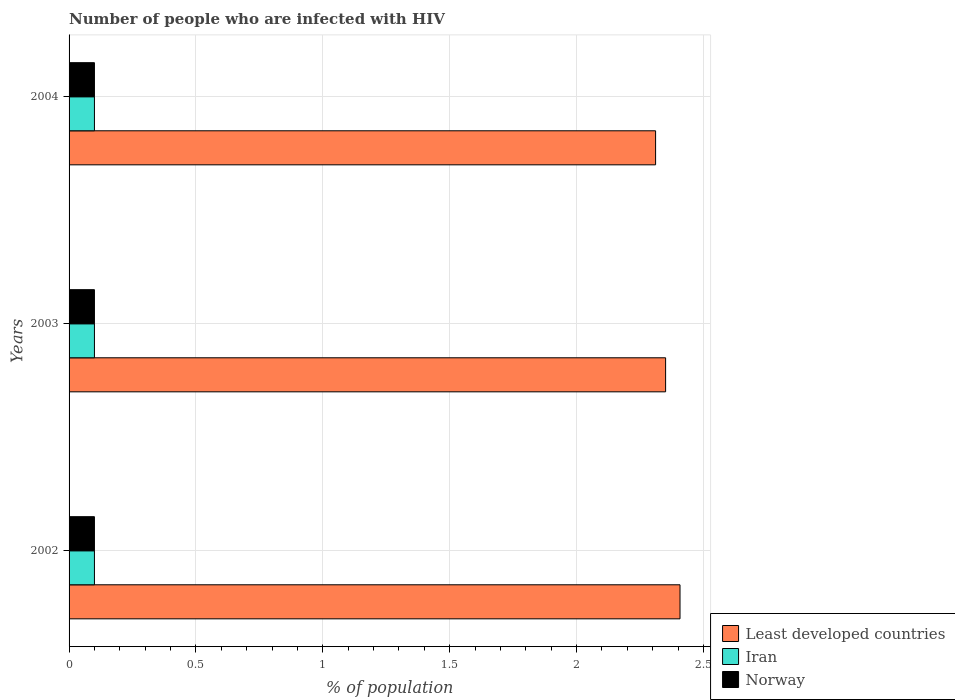Are the number of bars on each tick of the Y-axis equal?
Offer a terse response. Yes. How many bars are there on the 3rd tick from the top?
Keep it short and to the point. 3. How many bars are there on the 3rd tick from the bottom?
Provide a short and direct response. 3. In how many cases, is the number of bars for a given year not equal to the number of legend labels?
Provide a short and direct response. 0. Across all years, what is the maximum percentage of HIV infected population in in Least developed countries?
Make the answer very short. 2.41. Across all years, what is the minimum percentage of HIV infected population in in Iran?
Provide a succinct answer. 0.1. In which year was the percentage of HIV infected population in in Least developed countries minimum?
Ensure brevity in your answer.  2004. What is the total percentage of HIV infected population in in Least developed countries in the graph?
Your answer should be compact. 7.07. What is the average percentage of HIV infected population in in Iran per year?
Offer a terse response. 0.1. In the year 2002, what is the difference between the percentage of HIV infected population in in Least developed countries and percentage of HIV infected population in in Iran?
Make the answer very short. 2.31. What is the difference between the highest and the second highest percentage of HIV infected population in in Iran?
Offer a very short reply. 0. What is the difference between the highest and the lowest percentage of HIV infected population in in Iran?
Make the answer very short. 0. Is the sum of the percentage of HIV infected population in in Least developed countries in 2002 and 2003 greater than the maximum percentage of HIV infected population in in Norway across all years?
Offer a very short reply. Yes. What does the 2nd bar from the top in 2002 represents?
Offer a very short reply. Iran. What does the 2nd bar from the bottom in 2003 represents?
Offer a terse response. Iran. How many bars are there?
Your answer should be compact. 9. Are the values on the major ticks of X-axis written in scientific E-notation?
Give a very brief answer. No. Does the graph contain any zero values?
Offer a terse response. No. What is the title of the graph?
Offer a terse response. Number of people who are infected with HIV. What is the label or title of the X-axis?
Your answer should be very brief. % of population. What is the label or title of the Y-axis?
Make the answer very short. Years. What is the % of population in Least developed countries in 2002?
Offer a very short reply. 2.41. What is the % of population in Least developed countries in 2003?
Provide a short and direct response. 2.35. What is the % of population of Iran in 2003?
Keep it short and to the point. 0.1. What is the % of population in Least developed countries in 2004?
Your response must be concise. 2.31. What is the % of population in Iran in 2004?
Keep it short and to the point. 0.1. What is the % of population of Norway in 2004?
Provide a succinct answer. 0.1. Across all years, what is the maximum % of population in Least developed countries?
Keep it short and to the point. 2.41. Across all years, what is the maximum % of population in Iran?
Give a very brief answer. 0.1. Across all years, what is the maximum % of population of Norway?
Provide a succinct answer. 0.1. Across all years, what is the minimum % of population in Least developed countries?
Offer a very short reply. 2.31. Across all years, what is the minimum % of population in Iran?
Make the answer very short. 0.1. Across all years, what is the minimum % of population of Norway?
Offer a very short reply. 0.1. What is the total % of population in Least developed countries in the graph?
Provide a succinct answer. 7.07. What is the total % of population in Iran in the graph?
Your answer should be very brief. 0.3. What is the difference between the % of population of Least developed countries in 2002 and that in 2003?
Your response must be concise. 0.06. What is the difference between the % of population in Iran in 2002 and that in 2003?
Your answer should be very brief. 0. What is the difference between the % of population in Norway in 2002 and that in 2003?
Provide a succinct answer. 0. What is the difference between the % of population in Least developed countries in 2002 and that in 2004?
Your answer should be compact. 0.1. What is the difference between the % of population in Iran in 2002 and that in 2004?
Your answer should be compact. 0. What is the difference between the % of population in Norway in 2002 and that in 2004?
Your answer should be very brief. 0. What is the difference between the % of population in Least developed countries in 2003 and that in 2004?
Offer a very short reply. 0.04. What is the difference between the % of population in Iran in 2003 and that in 2004?
Keep it short and to the point. 0. What is the difference between the % of population in Least developed countries in 2002 and the % of population in Iran in 2003?
Provide a short and direct response. 2.31. What is the difference between the % of population in Least developed countries in 2002 and the % of population in Norway in 2003?
Your answer should be compact. 2.31. What is the difference between the % of population of Least developed countries in 2002 and the % of population of Iran in 2004?
Ensure brevity in your answer.  2.31. What is the difference between the % of population in Least developed countries in 2002 and the % of population in Norway in 2004?
Your answer should be compact. 2.31. What is the difference between the % of population in Least developed countries in 2003 and the % of population in Iran in 2004?
Make the answer very short. 2.25. What is the difference between the % of population in Least developed countries in 2003 and the % of population in Norway in 2004?
Provide a short and direct response. 2.25. What is the difference between the % of population of Iran in 2003 and the % of population of Norway in 2004?
Keep it short and to the point. 0. What is the average % of population in Least developed countries per year?
Your answer should be compact. 2.36. What is the average % of population of Norway per year?
Keep it short and to the point. 0.1. In the year 2002, what is the difference between the % of population of Least developed countries and % of population of Iran?
Provide a short and direct response. 2.31. In the year 2002, what is the difference between the % of population of Least developed countries and % of population of Norway?
Provide a succinct answer. 2.31. In the year 2002, what is the difference between the % of population in Iran and % of population in Norway?
Ensure brevity in your answer.  0. In the year 2003, what is the difference between the % of population in Least developed countries and % of population in Iran?
Keep it short and to the point. 2.25. In the year 2003, what is the difference between the % of population of Least developed countries and % of population of Norway?
Make the answer very short. 2.25. In the year 2003, what is the difference between the % of population in Iran and % of population in Norway?
Provide a succinct answer. 0. In the year 2004, what is the difference between the % of population in Least developed countries and % of population in Iran?
Offer a very short reply. 2.21. In the year 2004, what is the difference between the % of population in Least developed countries and % of population in Norway?
Give a very brief answer. 2.21. In the year 2004, what is the difference between the % of population in Iran and % of population in Norway?
Give a very brief answer. 0. What is the ratio of the % of population in Least developed countries in 2002 to that in 2003?
Your response must be concise. 1.02. What is the ratio of the % of population in Least developed countries in 2002 to that in 2004?
Keep it short and to the point. 1.04. What is the ratio of the % of population in Iran in 2002 to that in 2004?
Your answer should be very brief. 1. What is the ratio of the % of population in Norway in 2002 to that in 2004?
Your answer should be compact. 1. What is the ratio of the % of population of Least developed countries in 2003 to that in 2004?
Keep it short and to the point. 1.02. What is the difference between the highest and the second highest % of population in Least developed countries?
Your answer should be very brief. 0.06. What is the difference between the highest and the second highest % of population in Iran?
Give a very brief answer. 0. What is the difference between the highest and the lowest % of population of Least developed countries?
Keep it short and to the point. 0.1. What is the difference between the highest and the lowest % of population of Iran?
Your response must be concise. 0. What is the difference between the highest and the lowest % of population in Norway?
Keep it short and to the point. 0. 